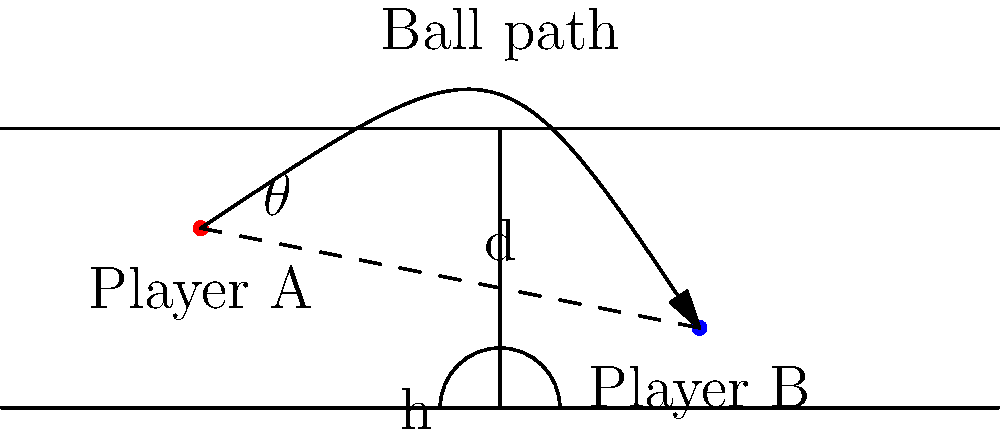In a crucial game moment, Player A wants to make an alley-oop pass to Player B. Given that Player A is at (-30, -10) and Player B is at (20, -20) on the court diagram, calculate:

a) The straight-line distance (d) between the players.
b) The angle (θ) of the pass relative to the horizontal baseline.

Round your answers to the nearest whole number for distance and to the nearest degree for the angle. Let's approach this step-by-step:

1. Calculate the distance (d):
   We can use the Pythagorean theorem to find the distance between the two points.
   
   $$ d = \sqrt{(x_2 - x_1)^2 + (y_2 - y_1)^2} $$
   $$ d = \sqrt{(20 - (-30))^2 + (-20 - (-10))^2} $$
   $$ d = \sqrt{50^2 + (-10)^2} $$
   $$ d = \sqrt{2500 + 100} = \sqrt{2600} \approx 50.99 $$

   Rounding to the nearest whole number: d ≈ 51 feet

2. Calculate the angle (θ):
   We can use the arctangent function to find the angle.
   First, calculate the horizontal (h) and vertical (v) distances:

   $$ h = 20 - (-30) = 50 $$
   $$ v = -20 - (-10) = -10 $$

   Now, use arctangent:
   $$ \theta = \arctan(\frac{v}{h}) = \arctan(\frac{-10}{50}) $$
   $$ \theta = \arctan(-0.2) \approx -11.31° $$

   The negative angle indicates a downward slope. Taking the absolute value and rounding to the nearest degree: θ ≈ 11°
Answer: d ≈ 51 feet, θ ≈ 11° 